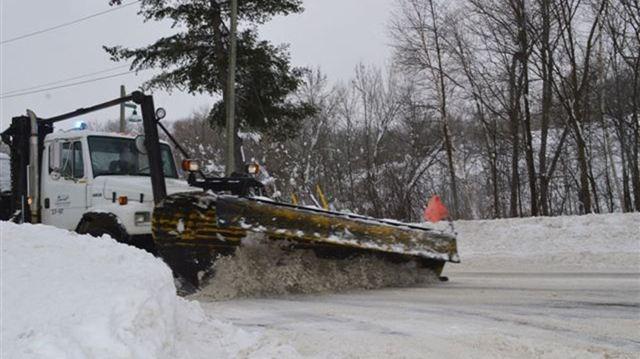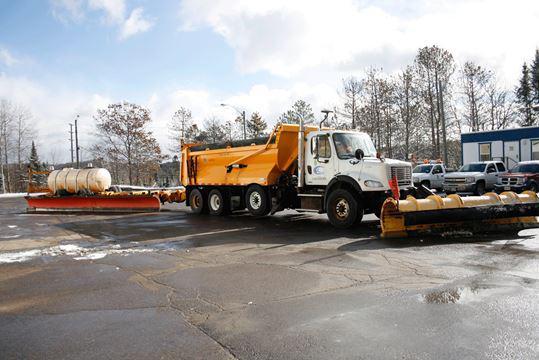The first image is the image on the left, the second image is the image on the right. Considering the images on both sides, is "At least one snow plow is driving down the road clearing snow." valid? Answer yes or no. Yes. The first image is the image on the left, the second image is the image on the right. Assess this claim about the two images: "None of these trucks are pushing snow.". Correct or not? Answer yes or no. No. 